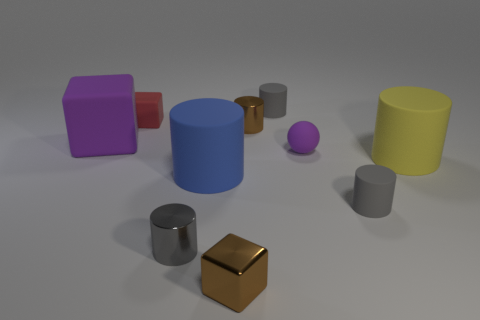Subtract all red balls. How many gray cylinders are left? 3 Subtract 2 cylinders. How many cylinders are left? 4 Subtract all brown cylinders. How many cylinders are left? 5 Subtract all yellow cylinders. How many cylinders are left? 5 Subtract all green cylinders. Subtract all blue cubes. How many cylinders are left? 6 Subtract all cubes. How many objects are left? 7 Add 5 tiny gray matte objects. How many tiny gray matte objects are left? 7 Add 6 big cubes. How many big cubes exist? 7 Subtract 0 gray blocks. How many objects are left? 10 Subtract all cyan rubber balls. Subtract all small metal blocks. How many objects are left? 9 